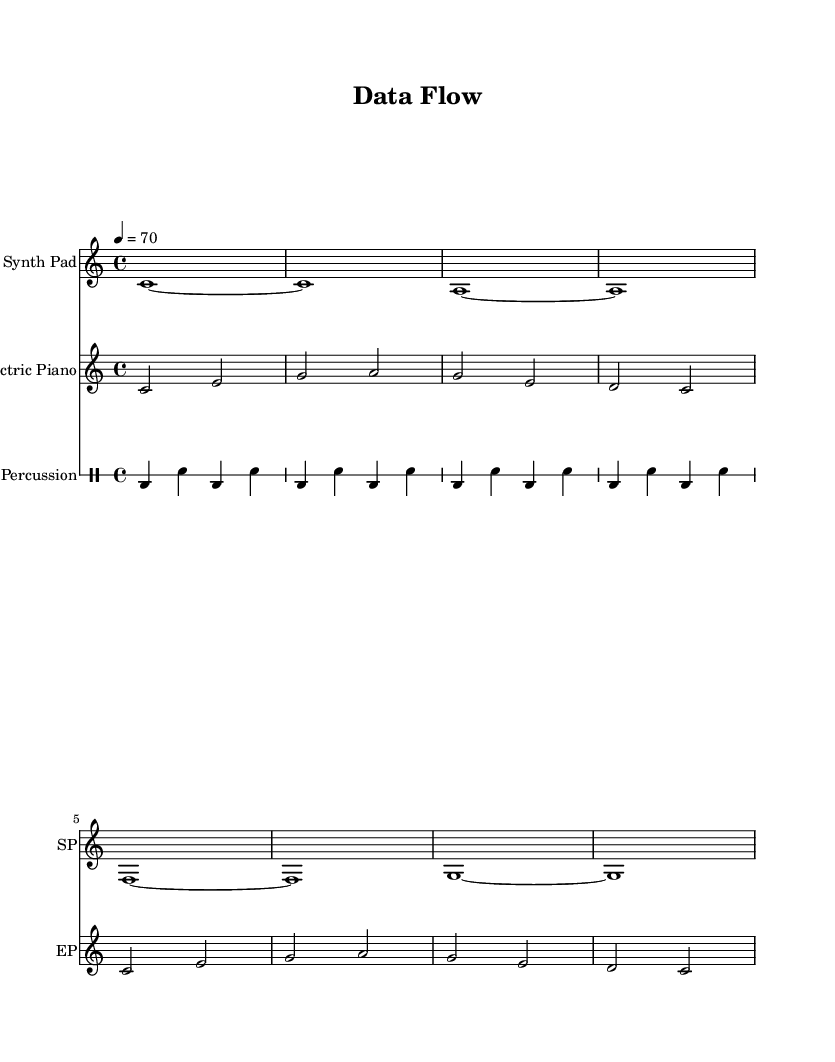what is the key signature of this music? The key signature is C major, which has no sharps or flats.
Answer: C major what is the time signature of this music? The time signature is indicated at the beginning of the score as 4/4, meaning there are four beats in each measure.
Answer: 4/4 what is the tempo marking of this music? The tempo marking indicates a speed of quarter note equals 70 beats per minute, which is typical for ambient music to promote concentration.
Answer: 70 how many measures are in the synth pad part? The synth pad consists of 8 measures, counting the individual sections that separate the repeated notes.
Answer: 8 what instruments are involved in this piece? The piece includes a Synth Pad, Electric Piano, and Percussion, each with their specific roles contributing to the ambient sound.
Answer: Synth Pad, Electric Piano, Percussion describe the rhythmic pattern of the percussion. The percussion part alternates between bass drum and snare drum in a regular pattern, creating a consistent pulse through four repeated measures.
Answer: Alternating (bass and snare) what feature makes this music suitable for concentration? The use of sustained chords from the synth pad and the soft dynamics of the electric piano create a tranquil soundscape that aids concentration.
Answer: Sustained chords 